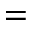<formula> <loc_0><loc_0><loc_500><loc_500>=</formula> 